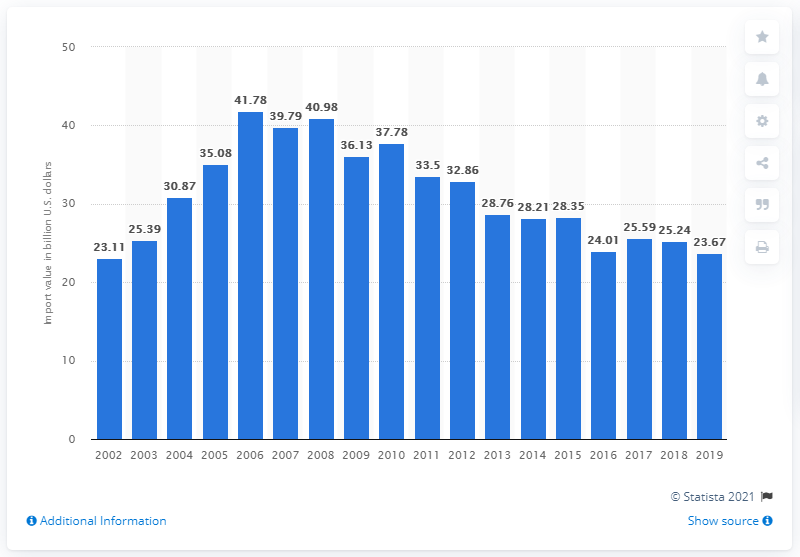Give some essential details in this illustration. The import of television and video equipment to the United States from 2002 to 2019 was valued at 23.67 billion dollars. 